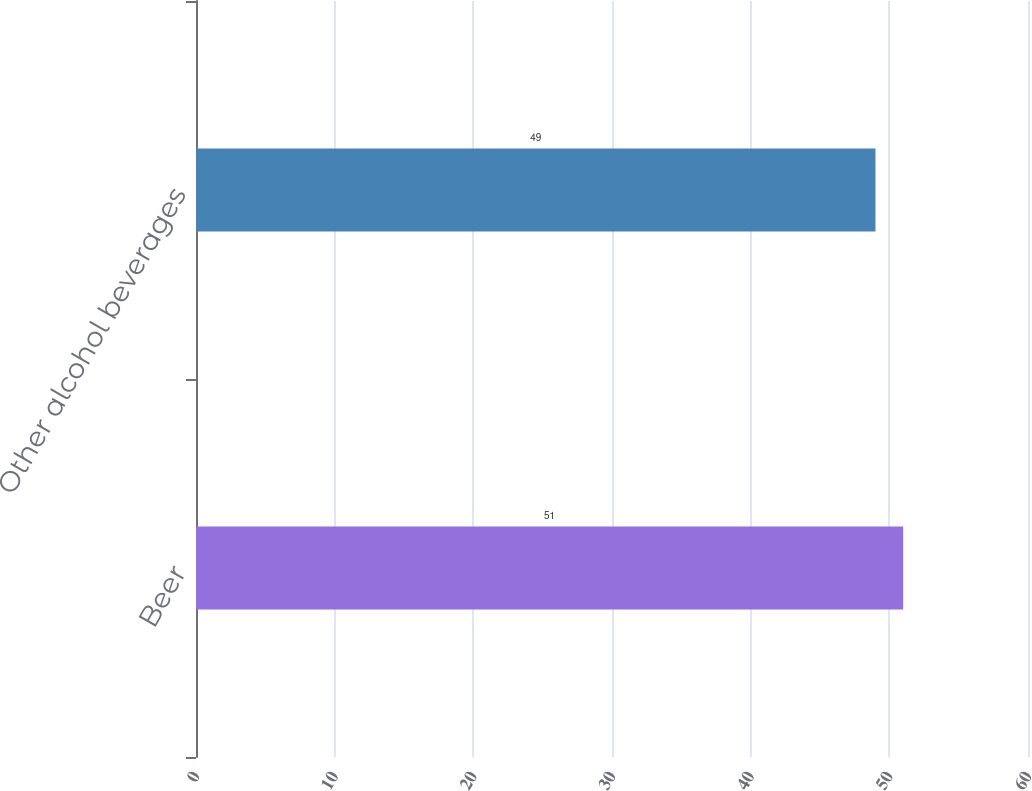<chart> <loc_0><loc_0><loc_500><loc_500><bar_chart><fcel>Beer<fcel>Other alcohol beverages<nl><fcel>51<fcel>49<nl></chart> 